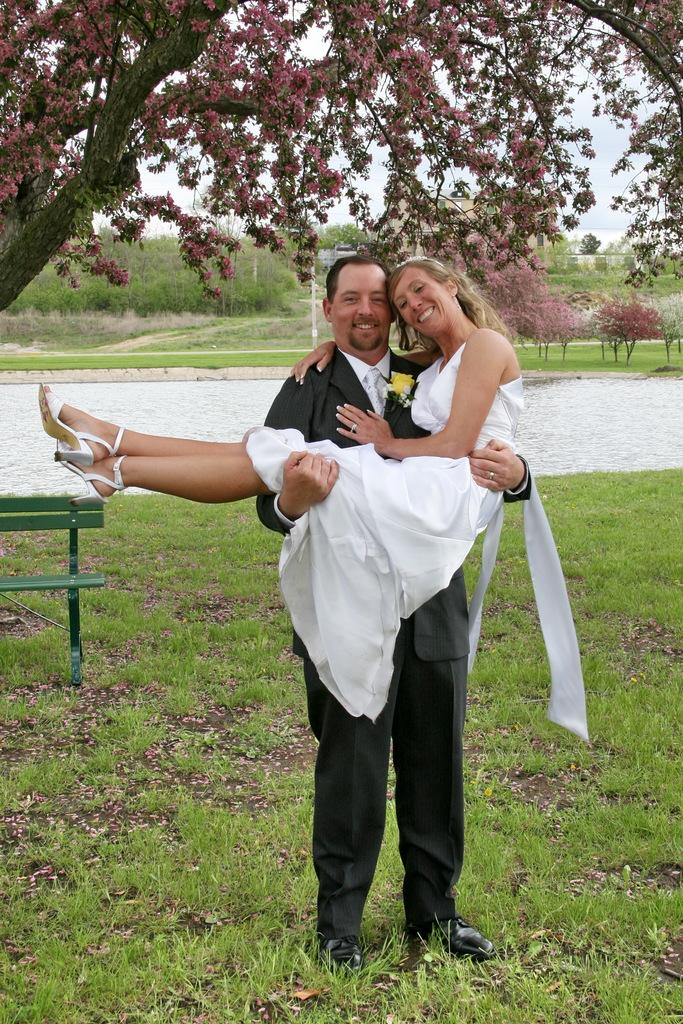What is happening between the man and the woman in the image? The man is carrying the woman in the image. What object can be seen in the image that people might sit on? There is a bench in the image. What type of vegetation is present in the image? There are trees, plants, and grass in the image. What part of the natural environment is visible in the image? The sky is visible in the image. What organization is responsible for controlling the growth of the plants in the image? There is no organization present in the image, and the growth of the plants is a natural process. What type of pot can be seen holding the plants in the image? There is no pot visible in the image; the plants are growing in the ground. 